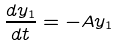Convert formula to latex. <formula><loc_0><loc_0><loc_500><loc_500>\frac { d y _ { 1 } } { d t } = - A y _ { 1 }</formula> 